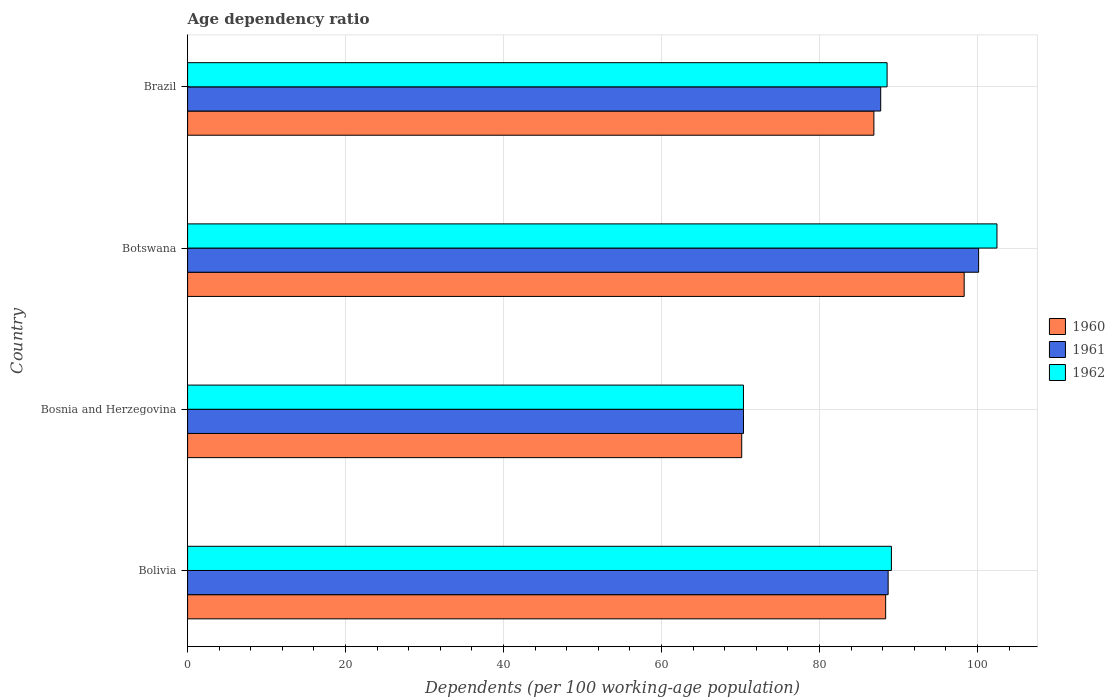What is the label of the 1st group of bars from the top?
Offer a terse response. Brazil. In how many cases, is the number of bars for a given country not equal to the number of legend labels?
Offer a terse response. 0. What is the age dependency ratio in in 1961 in Bosnia and Herzegovina?
Your answer should be very brief. 70.38. Across all countries, what is the maximum age dependency ratio in in 1961?
Make the answer very short. 100.15. Across all countries, what is the minimum age dependency ratio in in 1962?
Give a very brief answer. 70.38. In which country was the age dependency ratio in in 1961 maximum?
Your answer should be compact. Botswana. In which country was the age dependency ratio in in 1961 minimum?
Ensure brevity in your answer.  Bosnia and Herzegovina. What is the total age dependency ratio in in 1962 in the graph?
Offer a very short reply. 350.51. What is the difference between the age dependency ratio in in 1960 in Bosnia and Herzegovina and that in Botswana?
Your response must be concise. -28.16. What is the difference between the age dependency ratio in in 1960 in Bosnia and Herzegovina and the age dependency ratio in in 1962 in Brazil?
Keep it short and to the point. -18.4. What is the average age dependency ratio in in 1962 per country?
Provide a succinct answer. 87.63. What is the difference between the age dependency ratio in in 1961 and age dependency ratio in in 1962 in Bosnia and Herzegovina?
Provide a short and direct response. 0. What is the ratio of the age dependency ratio in in 1962 in Bolivia to that in Bosnia and Herzegovina?
Provide a short and direct response. 1.27. Is the difference between the age dependency ratio in in 1961 in Bolivia and Botswana greater than the difference between the age dependency ratio in in 1962 in Bolivia and Botswana?
Your answer should be very brief. Yes. What is the difference between the highest and the second highest age dependency ratio in in 1960?
Give a very brief answer. 9.94. What is the difference between the highest and the lowest age dependency ratio in in 1960?
Make the answer very short. 28.16. Is the sum of the age dependency ratio in in 1961 in Bosnia and Herzegovina and Brazil greater than the maximum age dependency ratio in in 1962 across all countries?
Your answer should be very brief. Yes. What does the 3rd bar from the bottom in Brazil represents?
Your answer should be compact. 1962. How many bars are there?
Keep it short and to the point. 12. Are the values on the major ticks of X-axis written in scientific E-notation?
Provide a short and direct response. No. Where does the legend appear in the graph?
Give a very brief answer. Center right. How are the legend labels stacked?
Your answer should be very brief. Vertical. What is the title of the graph?
Give a very brief answer. Age dependency ratio. What is the label or title of the X-axis?
Offer a terse response. Dependents (per 100 working-age population). What is the label or title of the Y-axis?
Offer a terse response. Country. What is the Dependents (per 100 working-age population) in 1960 in Bolivia?
Keep it short and to the point. 88.38. What is the Dependents (per 100 working-age population) of 1961 in Bolivia?
Offer a very short reply. 88.69. What is the Dependents (per 100 working-age population) of 1962 in Bolivia?
Your answer should be compact. 89.11. What is the Dependents (per 100 working-age population) in 1960 in Bosnia and Herzegovina?
Ensure brevity in your answer.  70.15. What is the Dependents (per 100 working-age population) in 1961 in Bosnia and Herzegovina?
Keep it short and to the point. 70.38. What is the Dependents (per 100 working-age population) in 1962 in Bosnia and Herzegovina?
Offer a very short reply. 70.38. What is the Dependents (per 100 working-age population) of 1960 in Botswana?
Make the answer very short. 98.32. What is the Dependents (per 100 working-age population) in 1961 in Botswana?
Make the answer very short. 100.15. What is the Dependents (per 100 working-age population) of 1962 in Botswana?
Make the answer very short. 102.47. What is the Dependents (per 100 working-age population) in 1960 in Brazil?
Provide a succinct answer. 86.89. What is the Dependents (per 100 working-age population) in 1961 in Brazil?
Provide a succinct answer. 87.75. What is the Dependents (per 100 working-age population) of 1962 in Brazil?
Provide a short and direct response. 88.56. Across all countries, what is the maximum Dependents (per 100 working-age population) in 1960?
Give a very brief answer. 98.32. Across all countries, what is the maximum Dependents (per 100 working-age population) of 1961?
Keep it short and to the point. 100.15. Across all countries, what is the maximum Dependents (per 100 working-age population) in 1962?
Your response must be concise. 102.47. Across all countries, what is the minimum Dependents (per 100 working-age population) in 1960?
Keep it short and to the point. 70.15. Across all countries, what is the minimum Dependents (per 100 working-age population) in 1961?
Make the answer very short. 70.38. Across all countries, what is the minimum Dependents (per 100 working-age population) of 1962?
Provide a short and direct response. 70.38. What is the total Dependents (per 100 working-age population) in 1960 in the graph?
Ensure brevity in your answer.  343.74. What is the total Dependents (per 100 working-age population) of 1961 in the graph?
Provide a short and direct response. 346.97. What is the total Dependents (per 100 working-age population) of 1962 in the graph?
Provide a succinct answer. 350.51. What is the difference between the Dependents (per 100 working-age population) of 1960 in Bolivia and that in Bosnia and Herzegovina?
Your answer should be very brief. 18.22. What is the difference between the Dependents (per 100 working-age population) of 1961 in Bolivia and that in Bosnia and Herzegovina?
Give a very brief answer. 18.31. What is the difference between the Dependents (per 100 working-age population) of 1962 in Bolivia and that in Bosnia and Herzegovina?
Offer a very short reply. 18.73. What is the difference between the Dependents (per 100 working-age population) in 1960 in Bolivia and that in Botswana?
Your response must be concise. -9.94. What is the difference between the Dependents (per 100 working-age population) in 1961 in Bolivia and that in Botswana?
Your response must be concise. -11.45. What is the difference between the Dependents (per 100 working-age population) of 1962 in Bolivia and that in Botswana?
Your response must be concise. -13.36. What is the difference between the Dependents (per 100 working-age population) of 1960 in Bolivia and that in Brazil?
Provide a short and direct response. 1.49. What is the difference between the Dependents (per 100 working-age population) of 1961 in Bolivia and that in Brazil?
Offer a terse response. 0.94. What is the difference between the Dependents (per 100 working-age population) of 1962 in Bolivia and that in Brazil?
Offer a terse response. 0.55. What is the difference between the Dependents (per 100 working-age population) in 1960 in Bosnia and Herzegovina and that in Botswana?
Provide a succinct answer. -28.16. What is the difference between the Dependents (per 100 working-age population) in 1961 in Bosnia and Herzegovina and that in Botswana?
Ensure brevity in your answer.  -29.77. What is the difference between the Dependents (per 100 working-age population) in 1962 in Bosnia and Herzegovina and that in Botswana?
Provide a short and direct response. -32.09. What is the difference between the Dependents (per 100 working-age population) in 1960 in Bosnia and Herzegovina and that in Brazil?
Offer a terse response. -16.73. What is the difference between the Dependents (per 100 working-age population) of 1961 in Bosnia and Herzegovina and that in Brazil?
Your answer should be compact. -17.37. What is the difference between the Dependents (per 100 working-age population) of 1962 in Bosnia and Herzegovina and that in Brazil?
Offer a very short reply. -18.18. What is the difference between the Dependents (per 100 working-age population) in 1960 in Botswana and that in Brazil?
Provide a succinct answer. 11.43. What is the difference between the Dependents (per 100 working-age population) of 1961 in Botswana and that in Brazil?
Your answer should be compact. 12.4. What is the difference between the Dependents (per 100 working-age population) in 1962 in Botswana and that in Brazil?
Make the answer very short. 13.91. What is the difference between the Dependents (per 100 working-age population) of 1960 in Bolivia and the Dependents (per 100 working-age population) of 1961 in Bosnia and Herzegovina?
Your answer should be compact. 18. What is the difference between the Dependents (per 100 working-age population) in 1960 in Bolivia and the Dependents (per 100 working-age population) in 1962 in Bosnia and Herzegovina?
Your answer should be compact. 18. What is the difference between the Dependents (per 100 working-age population) in 1961 in Bolivia and the Dependents (per 100 working-age population) in 1962 in Bosnia and Herzegovina?
Make the answer very short. 18.32. What is the difference between the Dependents (per 100 working-age population) in 1960 in Bolivia and the Dependents (per 100 working-age population) in 1961 in Botswana?
Your response must be concise. -11.77. What is the difference between the Dependents (per 100 working-age population) of 1960 in Bolivia and the Dependents (per 100 working-age population) of 1962 in Botswana?
Your response must be concise. -14.09. What is the difference between the Dependents (per 100 working-age population) in 1961 in Bolivia and the Dependents (per 100 working-age population) in 1962 in Botswana?
Ensure brevity in your answer.  -13.78. What is the difference between the Dependents (per 100 working-age population) in 1960 in Bolivia and the Dependents (per 100 working-age population) in 1961 in Brazil?
Make the answer very short. 0.63. What is the difference between the Dependents (per 100 working-age population) in 1960 in Bolivia and the Dependents (per 100 working-age population) in 1962 in Brazil?
Your answer should be compact. -0.18. What is the difference between the Dependents (per 100 working-age population) of 1961 in Bolivia and the Dependents (per 100 working-age population) of 1962 in Brazil?
Your answer should be very brief. 0.13. What is the difference between the Dependents (per 100 working-age population) of 1960 in Bosnia and Herzegovina and the Dependents (per 100 working-age population) of 1961 in Botswana?
Your answer should be compact. -29.99. What is the difference between the Dependents (per 100 working-age population) of 1960 in Bosnia and Herzegovina and the Dependents (per 100 working-age population) of 1962 in Botswana?
Give a very brief answer. -32.31. What is the difference between the Dependents (per 100 working-age population) in 1961 in Bosnia and Herzegovina and the Dependents (per 100 working-age population) in 1962 in Botswana?
Offer a terse response. -32.09. What is the difference between the Dependents (per 100 working-age population) in 1960 in Bosnia and Herzegovina and the Dependents (per 100 working-age population) in 1961 in Brazil?
Provide a short and direct response. -17.6. What is the difference between the Dependents (per 100 working-age population) in 1960 in Bosnia and Herzegovina and the Dependents (per 100 working-age population) in 1962 in Brazil?
Give a very brief answer. -18.4. What is the difference between the Dependents (per 100 working-age population) in 1961 in Bosnia and Herzegovina and the Dependents (per 100 working-age population) in 1962 in Brazil?
Make the answer very short. -18.18. What is the difference between the Dependents (per 100 working-age population) of 1960 in Botswana and the Dependents (per 100 working-age population) of 1961 in Brazil?
Provide a succinct answer. 10.57. What is the difference between the Dependents (per 100 working-age population) of 1960 in Botswana and the Dependents (per 100 working-age population) of 1962 in Brazil?
Keep it short and to the point. 9.76. What is the difference between the Dependents (per 100 working-age population) of 1961 in Botswana and the Dependents (per 100 working-age population) of 1962 in Brazil?
Offer a terse response. 11.59. What is the average Dependents (per 100 working-age population) in 1960 per country?
Keep it short and to the point. 85.94. What is the average Dependents (per 100 working-age population) in 1961 per country?
Your answer should be compact. 86.74. What is the average Dependents (per 100 working-age population) in 1962 per country?
Make the answer very short. 87.63. What is the difference between the Dependents (per 100 working-age population) in 1960 and Dependents (per 100 working-age population) in 1961 in Bolivia?
Your response must be concise. -0.31. What is the difference between the Dependents (per 100 working-age population) in 1960 and Dependents (per 100 working-age population) in 1962 in Bolivia?
Ensure brevity in your answer.  -0.73. What is the difference between the Dependents (per 100 working-age population) in 1961 and Dependents (per 100 working-age population) in 1962 in Bolivia?
Offer a very short reply. -0.41. What is the difference between the Dependents (per 100 working-age population) in 1960 and Dependents (per 100 working-age population) in 1961 in Bosnia and Herzegovina?
Offer a terse response. -0.22. What is the difference between the Dependents (per 100 working-age population) in 1960 and Dependents (per 100 working-age population) in 1962 in Bosnia and Herzegovina?
Ensure brevity in your answer.  -0.22. What is the difference between the Dependents (per 100 working-age population) in 1961 and Dependents (per 100 working-age population) in 1962 in Bosnia and Herzegovina?
Your response must be concise. 0. What is the difference between the Dependents (per 100 working-age population) of 1960 and Dependents (per 100 working-age population) of 1961 in Botswana?
Your response must be concise. -1.83. What is the difference between the Dependents (per 100 working-age population) of 1960 and Dependents (per 100 working-age population) of 1962 in Botswana?
Provide a short and direct response. -4.15. What is the difference between the Dependents (per 100 working-age population) in 1961 and Dependents (per 100 working-age population) in 1962 in Botswana?
Offer a very short reply. -2.32. What is the difference between the Dependents (per 100 working-age population) of 1960 and Dependents (per 100 working-age population) of 1961 in Brazil?
Provide a succinct answer. -0.86. What is the difference between the Dependents (per 100 working-age population) of 1960 and Dependents (per 100 working-age population) of 1962 in Brazil?
Offer a very short reply. -1.67. What is the difference between the Dependents (per 100 working-age population) in 1961 and Dependents (per 100 working-age population) in 1962 in Brazil?
Offer a very short reply. -0.81. What is the ratio of the Dependents (per 100 working-age population) of 1960 in Bolivia to that in Bosnia and Herzegovina?
Keep it short and to the point. 1.26. What is the ratio of the Dependents (per 100 working-age population) of 1961 in Bolivia to that in Bosnia and Herzegovina?
Offer a very short reply. 1.26. What is the ratio of the Dependents (per 100 working-age population) in 1962 in Bolivia to that in Bosnia and Herzegovina?
Your answer should be compact. 1.27. What is the ratio of the Dependents (per 100 working-age population) of 1960 in Bolivia to that in Botswana?
Give a very brief answer. 0.9. What is the ratio of the Dependents (per 100 working-age population) of 1961 in Bolivia to that in Botswana?
Give a very brief answer. 0.89. What is the ratio of the Dependents (per 100 working-age population) of 1962 in Bolivia to that in Botswana?
Your answer should be compact. 0.87. What is the ratio of the Dependents (per 100 working-age population) in 1960 in Bolivia to that in Brazil?
Your answer should be compact. 1.02. What is the ratio of the Dependents (per 100 working-age population) of 1961 in Bolivia to that in Brazil?
Give a very brief answer. 1.01. What is the ratio of the Dependents (per 100 working-age population) in 1962 in Bolivia to that in Brazil?
Offer a very short reply. 1.01. What is the ratio of the Dependents (per 100 working-age population) of 1960 in Bosnia and Herzegovina to that in Botswana?
Your response must be concise. 0.71. What is the ratio of the Dependents (per 100 working-age population) of 1961 in Bosnia and Herzegovina to that in Botswana?
Provide a short and direct response. 0.7. What is the ratio of the Dependents (per 100 working-age population) of 1962 in Bosnia and Herzegovina to that in Botswana?
Make the answer very short. 0.69. What is the ratio of the Dependents (per 100 working-age population) of 1960 in Bosnia and Herzegovina to that in Brazil?
Give a very brief answer. 0.81. What is the ratio of the Dependents (per 100 working-age population) of 1961 in Bosnia and Herzegovina to that in Brazil?
Your response must be concise. 0.8. What is the ratio of the Dependents (per 100 working-age population) of 1962 in Bosnia and Herzegovina to that in Brazil?
Offer a terse response. 0.79. What is the ratio of the Dependents (per 100 working-age population) in 1960 in Botswana to that in Brazil?
Offer a very short reply. 1.13. What is the ratio of the Dependents (per 100 working-age population) of 1961 in Botswana to that in Brazil?
Ensure brevity in your answer.  1.14. What is the ratio of the Dependents (per 100 working-age population) in 1962 in Botswana to that in Brazil?
Make the answer very short. 1.16. What is the difference between the highest and the second highest Dependents (per 100 working-age population) of 1960?
Keep it short and to the point. 9.94. What is the difference between the highest and the second highest Dependents (per 100 working-age population) of 1961?
Provide a short and direct response. 11.45. What is the difference between the highest and the second highest Dependents (per 100 working-age population) in 1962?
Your answer should be compact. 13.36. What is the difference between the highest and the lowest Dependents (per 100 working-age population) of 1960?
Ensure brevity in your answer.  28.16. What is the difference between the highest and the lowest Dependents (per 100 working-age population) of 1961?
Provide a succinct answer. 29.77. What is the difference between the highest and the lowest Dependents (per 100 working-age population) of 1962?
Offer a terse response. 32.09. 